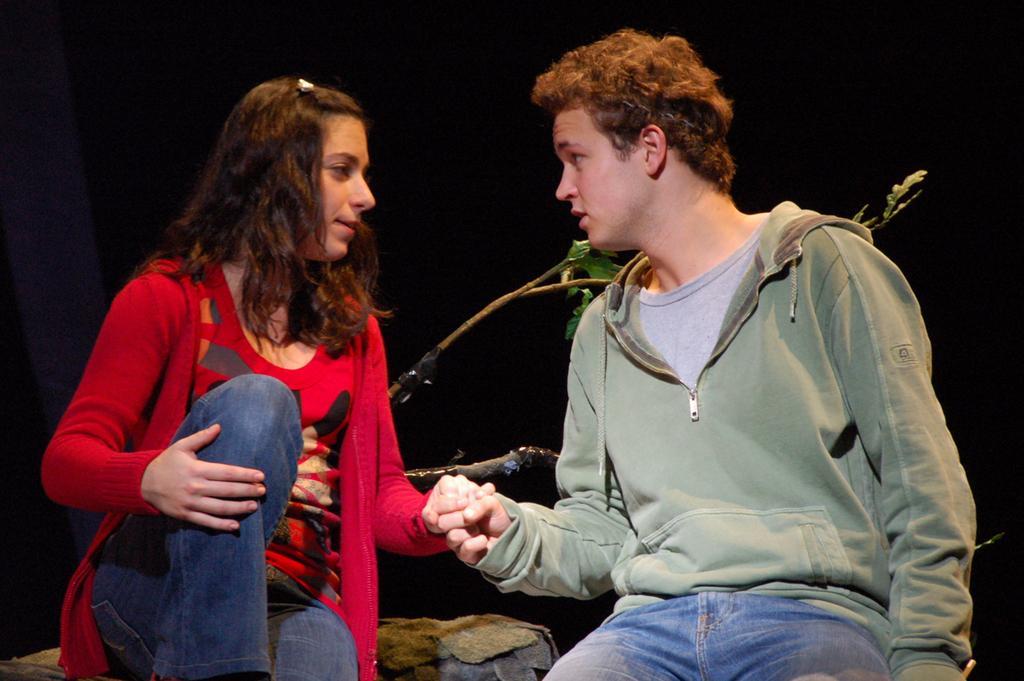Please provide a concise description of this image. Here is the man and woman sitting and holding each other hands. This looks like a rock. I think this is a plant. The background looks dark. 